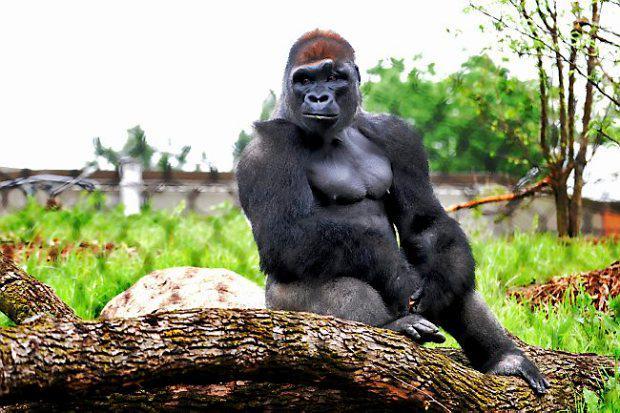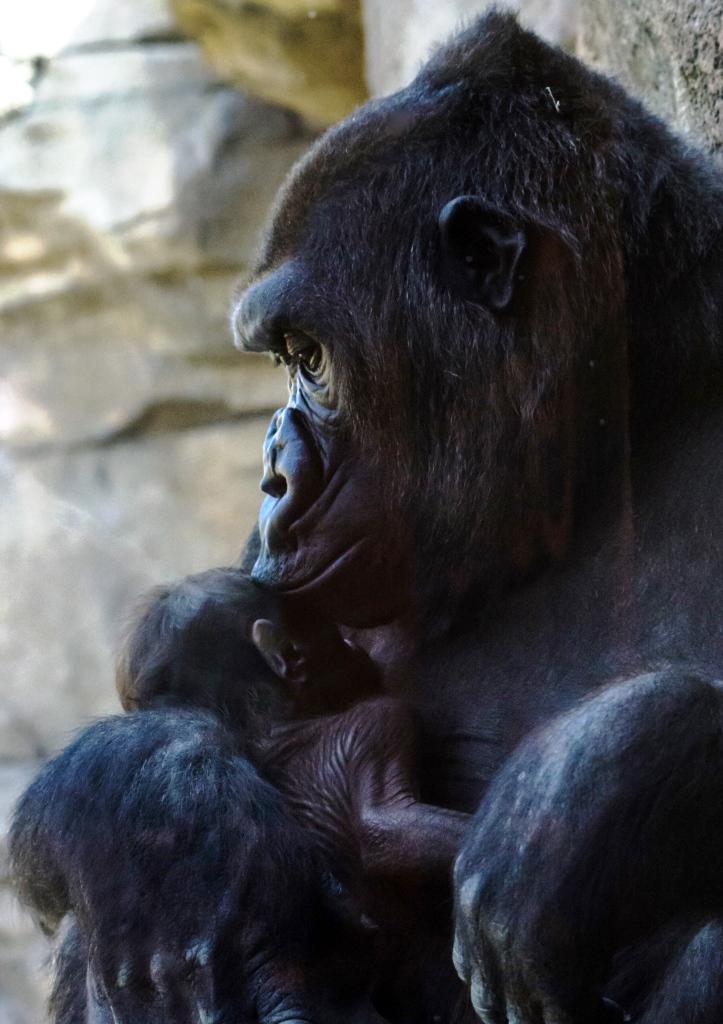The first image is the image on the left, the second image is the image on the right. For the images displayed, is the sentence "There are exactly two gorillas in total." factually correct? Answer yes or no. Yes. The first image is the image on the left, the second image is the image on the right. Examine the images to the left and right. Is the description "One image contains twice as many apes as the other image and includes a baby gorilla." accurate? Answer yes or no. Yes. 